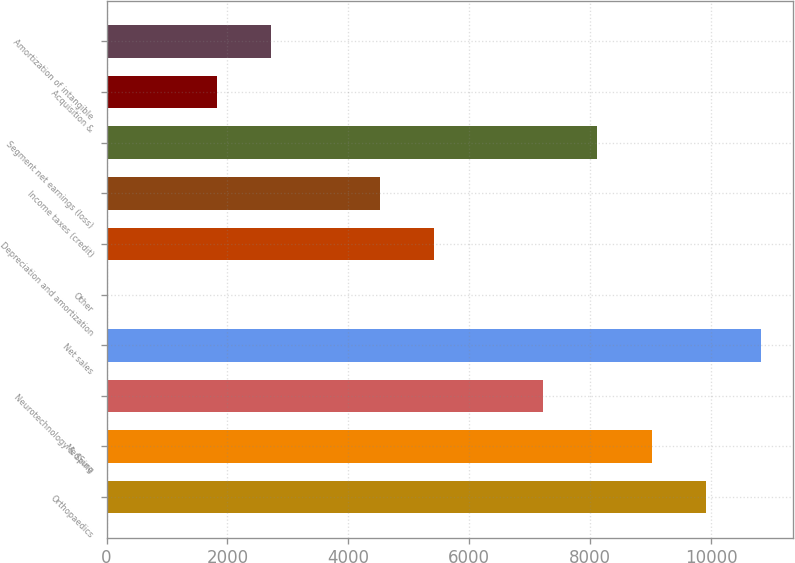<chart> <loc_0><loc_0><loc_500><loc_500><bar_chart><fcel>Orthopaedics<fcel>MedSurg<fcel>Neurotechnology & Spine<fcel>Net sales<fcel>Other<fcel>Depreciation and amortization<fcel>Income taxes (credit)<fcel>Segment net earnings (loss)<fcel>Acquisition &<fcel>Amortization of intangible<nl><fcel>9921.2<fcel>9021<fcel>7220.6<fcel>10821.4<fcel>19<fcel>5420.2<fcel>4520<fcel>8120.8<fcel>1819.4<fcel>2719.6<nl></chart> 